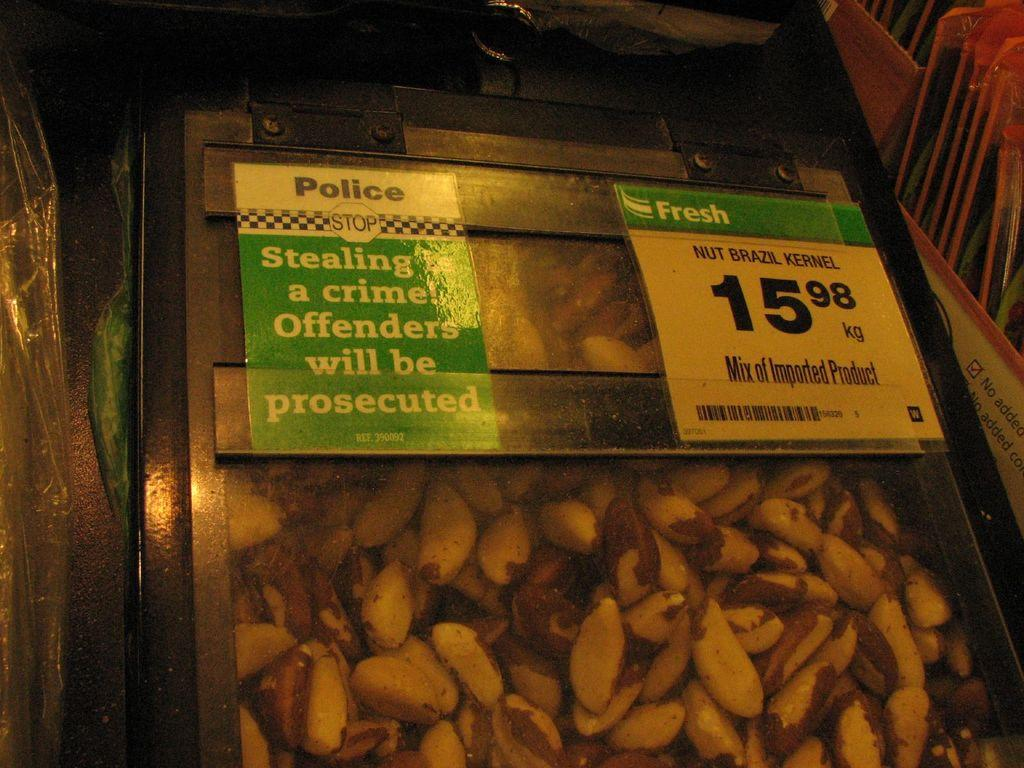What type of food is shown in the image? There are nut Brazil kernels in the image. Are there any additional items or features related to the nuts? Yes, there are two papers pasted on the box containing the nuts. What type of coat is the representative wearing in the image? There is no representative or coat present in the image; it only features nut Brazil kernels and papers pasted on a box. 